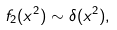<formula> <loc_0><loc_0><loc_500><loc_500>f _ { 2 } ( x ^ { 2 } ) \sim \delta ( { x ^ { 2 } } ) ,</formula> 